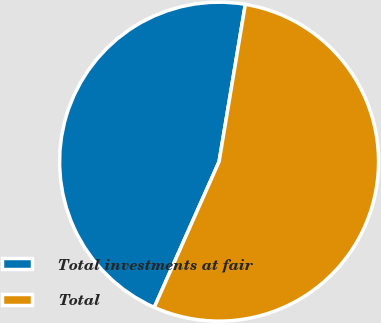Convert chart to OTSL. <chart><loc_0><loc_0><loc_500><loc_500><pie_chart><fcel>Total investments at fair<fcel>Total<nl><fcel>45.97%<fcel>54.03%<nl></chart> 